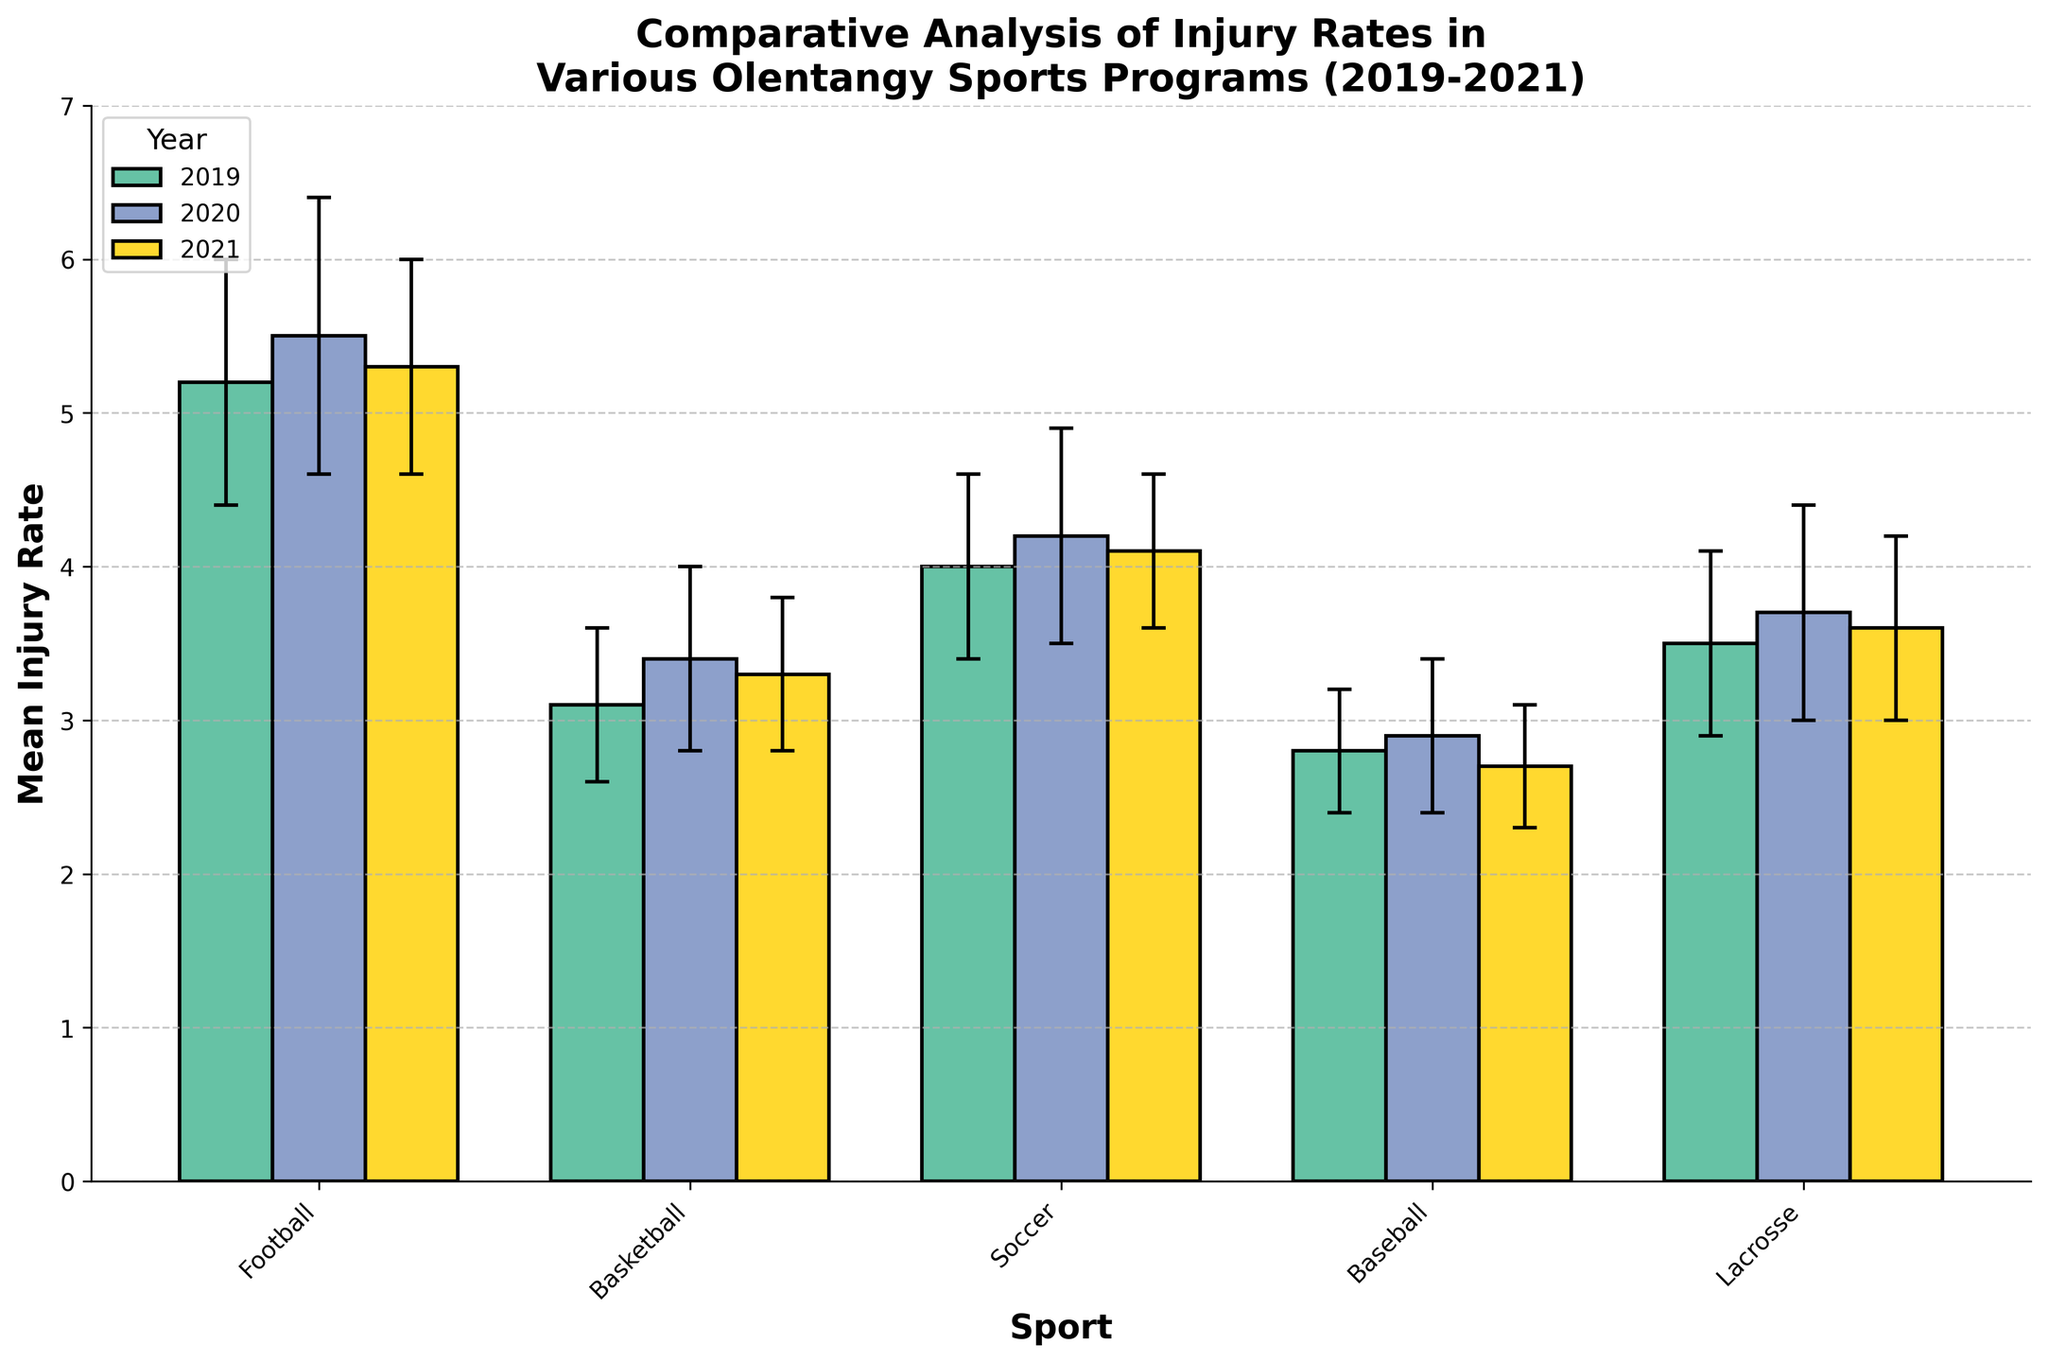What is the title of the figure? The title is usually displayed at the top of the chart. In this case, it states the purpose and context of the figure.
Answer: Comparative Analysis of Injury Rates in Various Olentangy Sports Programs (2019-2021) Which sport had the highest mean injury rate in 2020? To determine this, look for the highest bar representing the year 2020. The sport with the highest bar in 2020 is Football with a mean injury rate of 5.5.
Answer: Football What is the mean injury rate for Soccer in 2019? Find the bar labeled 2019 under Soccer. The height of this bar shows the mean injury rate, which is noted on the Y-axis.
Answer: 4.0 Between which years did Basketball see an increase in injury rates? Compare the heights of the bars for Basketball in different years. The mean injury rate for Basketball increased from 2019 (3.1) to 2020 (3.4).
Answer: From 2019 to 2020 What is the range of mean injury rates for Baseball across the three years? The range is the difference between the highest and lowest mean injury rates. For Baseball, the highest is 2.9 (2020) and the lowest is 2.7 (2021). The range is 2.9 - 2.7 = 0.2.
Answer: 0.2 Which sport had the biggest drop in mean injury rate from 2020 to 2021? Calculate the difference in mean injury rates between 2020 and 2021 for each sport and find the largest drop. Football had rates of 5.5 in 2020 and 5.3 in 2021, a drop of 0.2. Other sports had smaller differences or increases.
Answer: Football What is the standard deviation for Lacrosse in 2020? The standard deviation is represented by the error bar. For Lacrosse in 2020, it is indicated as 0.7.
Answer: 0.7 How does the mean injury rate of Soccer in 2021 compare to that of Basketball in 2019? Find the mean injury rate for Soccer in 2021 and Basketball in 2019. Soccer (2021) is 4.1 and Basketball (2019) is 3.1. Soccer's rate is higher by 1.0.
Answer: Soccer's rate is higher by 1.0 Which sport showed the least variation in mean injury rate over the three years? Evaluate the length of the error bars (standard deviations) for each sport over the three years. Baseball generally has small error bars (0.4, 0.5, and 0.4), indicating the least variation.
Answer: Baseball What is the average mean injury rate for all sports in 2021? Sum the mean injury rates of all sports for 2021 and divide by the number of sports. (5.3 + 3.3 + 4.1 + 2.7 + 3.6)/5 = 19/5 = 3.8.
Answer: 3.8 